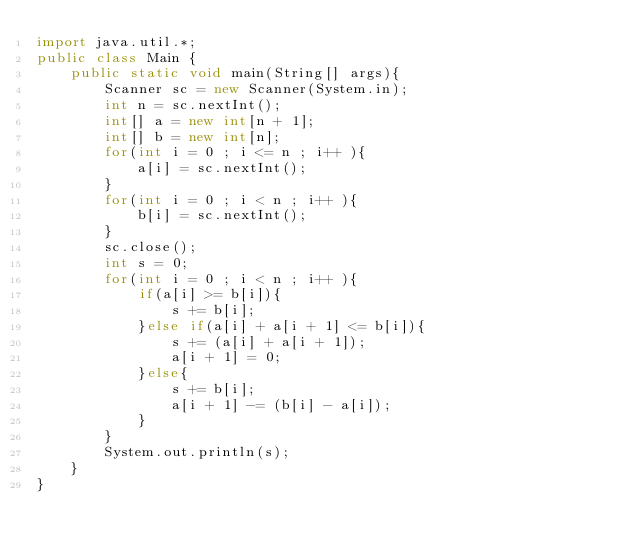Convert code to text. <code><loc_0><loc_0><loc_500><loc_500><_Java_>import java.util.*;
public class Main {
    public static void main(String[] args){
        Scanner sc = new Scanner(System.in);
        int n = sc.nextInt();
        int[] a = new int[n + 1];
        int[] b = new int[n];
        for(int i = 0 ; i <= n ; i++ ){
            a[i] = sc.nextInt();
        }
        for(int i = 0 ; i < n ; i++ ){
            b[i] = sc.nextInt();
        }
        sc.close();
        int s = 0;
        for(int i = 0 ; i < n ; i++ ){
            if(a[i] >= b[i]){
                s += b[i];
            }else if(a[i] + a[i + 1] <= b[i]){
                s += (a[i] + a[i + 1]);
                a[i + 1] = 0;
            }else{
                s += b[i];
                a[i + 1] -= (b[i] - a[i]);
            }
        }
        System.out.println(s);
    }
}</code> 